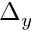<formula> <loc_0><loc_0><loc_500><loc_500>\Delta _ { y }</formula> 